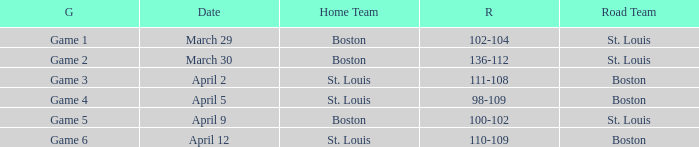What is the Game number on March 30? Game 2. 